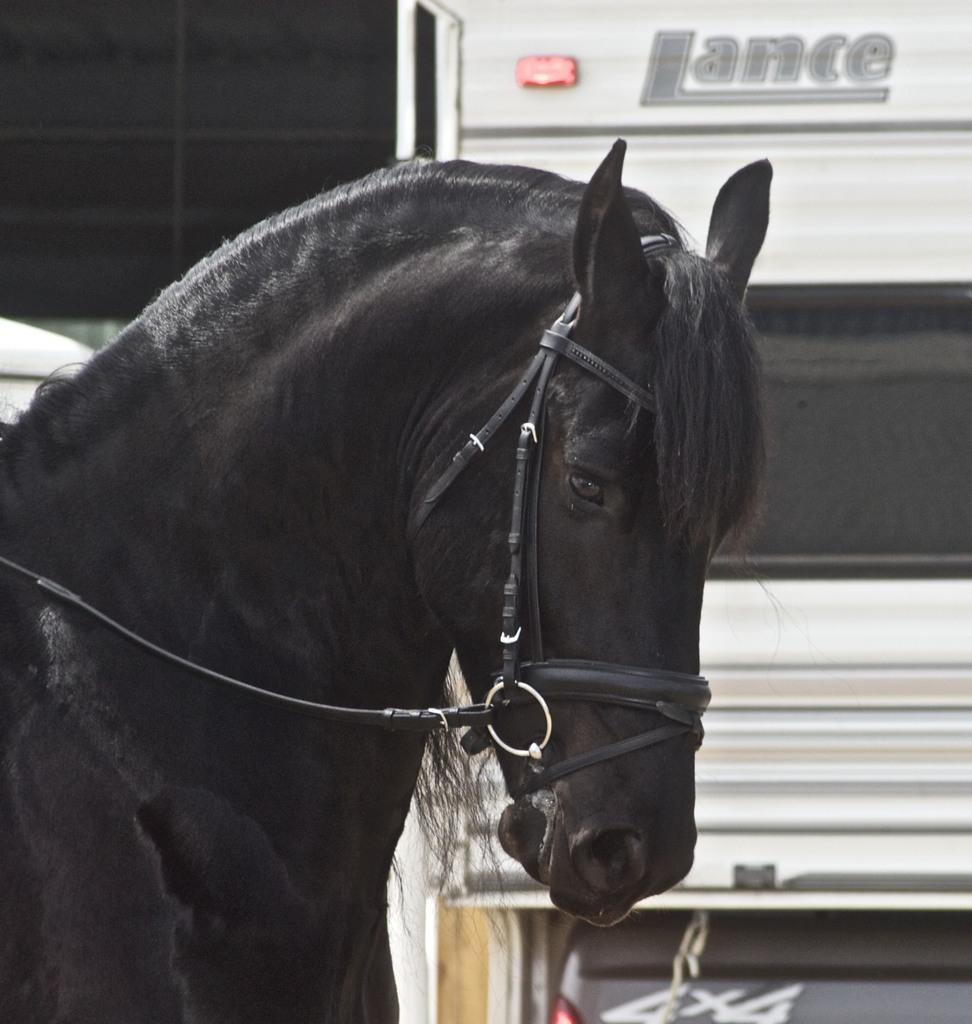What type of animal is in the image? There is a horse in the image. What else can be seen in the image besides the horse? There is a vehicle visible in the image. What is written or displayed on the vehicle? There is text on the vehicle. What type of muscle is being traded in the image? There is no mention of muscle or trading in the image; it features a horse and a vehicle with text. 